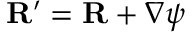Convert formula to latex. <formula><loc_0><loc_0><loc_500><loc_500>{ R } ^ { \prime } = { R } + \nabla \psi</formula> 